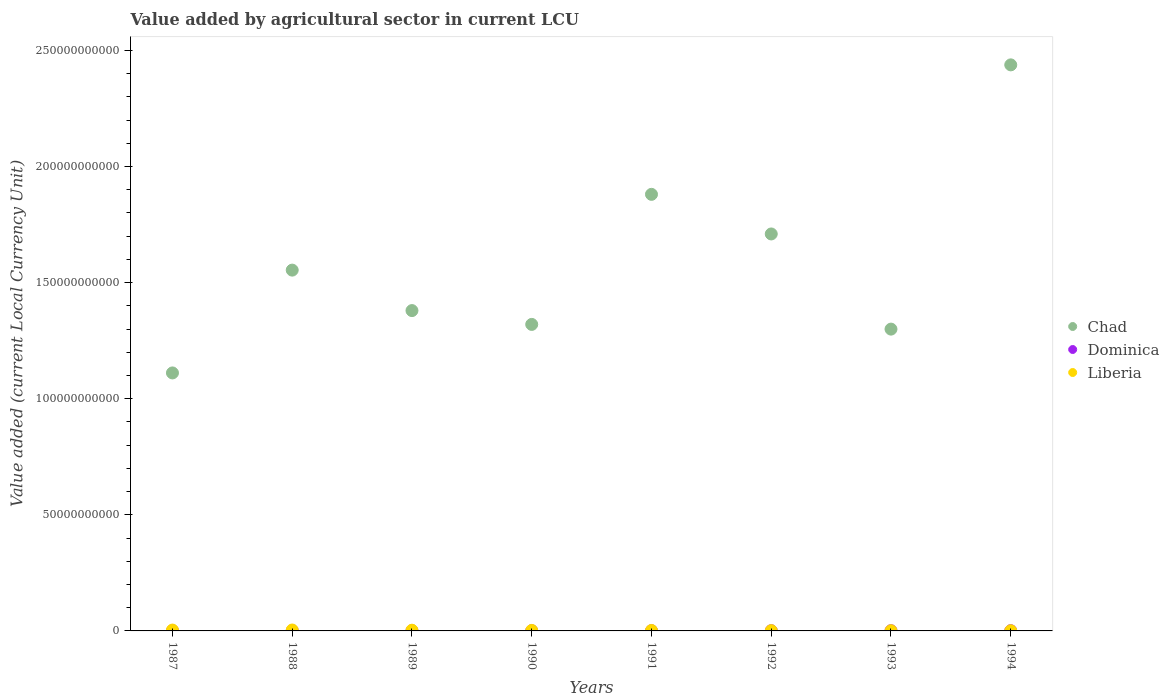How many different coloured dotlines are there?
Offer a very short reply. 3. What is the value added by agricultural sector in Liberia in 1987?
Ensure brevity in your answer.  3.71e+08. Across all years, what is the maximum value added by agricultural sector in Liberia?
Keep it short and to the point. 3.96e+08. Across all years, what is the minimum value added by agricultural sector in Liberia?
Keep it short and to the point. 6.93e+07. In which year was the value added by agricultural sector in Dominica maximum?
Offer a terse response. 1994. What is the total value added by agricultural sector in Chad in the graph?
Your answer should be very brief. 1.27e+12. What is the difference between the value added by agricultural sector in Chad in 1988 and that in 1992?
Your answer should be compact. -1.56e+1. What is the difference between the value added by agricultural sector in Liberia in 1991 and the value added by agricultural sector in Dominica in 1987?
Your response must be concise. 1.09e+08. What is the average value added by agricultural sector in Liberia per year?
Your answer should be very brief. 2.17e+08. In the year 1987, what is the difference between the value added by agricultural sector in Dominica and value added by agricultural sector in Chad?
Your response must be concise. -1.11e+11. What is the ratio of the value added by agricultural sector in Chad in 1987 to that in 1993?
Your answer should be very brief. 0.85. Is the difference between the value added by agricultural sector in Dominica in 1989 and 1990 greater than the difference between the value added by agricultural sector in Chad in 1989 and 1990?
Offer a terse response. No. What is the difference between the highest and the second highest value added by agricultural sector in Chad?
Offer a very short reply. 5.58e+1. What is the difference between the highest and the lowest value added by agricultural sector in Chad?
Give a very brief answer. 1.33e+11. Is it the case that in every year, the sum of the value added by agricultural sector in Dominica and value added by agricultural sector in Chad  is greater than the value added by agricultural sector in Liberia?
Give a very brief answer. Yes. Does the value added by agricultural sector in Chad monotonically increase over the years?
Ensure brevity in your answer.  No. How many dotlines are there?
Offer a terse response. 3. What is the difference between two consecutive major ticks on the Y-axis?
Your answer should be compact. 5.00e+1. Are the values on the major ticks of Y-axis written in scientific E-notation?
Give a very brief answer. No. Does the graph contain any zero values?
Ensure brevity in your answer.  No. How many legend labels are there?
Give a very brief answer. 3. What is the title of the graph?
Keep it short and to the point. Value added by agricultural sector in current LCU. What is the label or title of the Y-axis?
Offer a terse response. Value added (current Local Currency Unit). What is the Value added (current Local Currency Unit) in Chad in 1987?
Ensure brevity in your answer.  1.11e+11. What is the Value added (current Local Currency Unit) in Dominica in 1987?
Your response must be concise. 8.45e+07. What is the Value added (current Local Currency Unit) of Liberia in 1987?
Make the answer very short. 3.71e+08. What is the Value added (current Local Currency Unit) in Chad in 1988?
Ensure brevity in your answer.  1.55e+11. What is the Value added (current Local Currency Unit) of Dominica in 1988?
Ensure brevity in your answer.  9.08e+07. What is the Value added (current Local Currency Unit) in Liberia in 1988?
Provide a short and direct response. 3.96e+08. What is the Value added (current Local Currency Unit) of Chad in 1989?
Give a very brief answer. 1.38e+11. What is the Value added (current Local Currency Unit) in Dominica in 1989?
Offer a terse response. 8.09e+07. What is the Value added (current Local Currency Unit) of Liberia in 1989?
Offer a terse response. 3.04e+08. What is the Value added (current Local Currency Unit) in Chad in 1990?
Keep it short and to the point. 1.32e+11. What is the Value added (current Local Currency Unit) in Dominica in 1990?
Provide a short and direct response. 9.25e+07. What is the Value added (current Local Currency Unit) of Liberia in 1990?
Your answer should be very brief. 2.09e+08. What is the Value added (current Local Currency Unit) in Chad in 1991?
Make the answer very short. 1.88e+11. What is the Value added (current Local Currency Unit) in Dominica in 1991?
Your answer should be compact. 9.69e+07. What is the Value added (current Local Currency Unit) in Liberia in 1991?
Your answer should be very brief. 1.94e+08. What is the Value added (current Local Currency Unit) of Chad in 1992?
Your answer should be very brief. 1.71e+11. What is the Value added (current Local Currency Unit) in Dominica in 1992?
Offer a very short reply. 9.76e+07. What is the Value added (current Local Currency Unit) in Liberia in 1992?
Give a very brief answer. 1.15e+08. What is the Value added (current Local Currency Unit) of Chad in 1993?
Provide a short and direct response. 1.30e+11. What is the Value added (current Local Currency Unit) of Dominica in 1993?
Provide a succinct answer. 9.80e+07. What is the Value added (current Local Currency Unit) in Liberia in 1993?
Offer a terse response. 8.12e+07. What is the Value added (current Local Currency Unit) in Chad in 1994?
Provide a succinct answer. 2.44e+11. What is the Value added (current Local Currency Unit) of Dominica in 1994?
Provide a short and direct response. 1.07e+08. What is the Value added (current Local Currency Unit) in Liberia in 1994?
Your answer should be very brief. 6.93e+07. Across all years, what is the maximum Value added (current Local Currency Unit) of Chad?
Keep it short and to the point. 2.44e+11. Across all years, what is the maximum Value added (current Local Currency Unit) in Dominica?
Offer a very short reply. 1.07e+08. Across all years, what is the maximum Value added (current Local Currency Unit) in Liberia?
Provide a short and direct response. 3.96e+08. Across all years, what is the minimum Value added (current Local Currency Unit) of Chad?
Make the answer very short. 1.11e+11. Across all years, what is the minimum Value added (current Local Currency Unit) of Dominica?
Keep it short and to the point. 8.09e+07. Across all years, what is the minimum Value added (current Local Currency Unit) in Liberia?
Keep it short and to the point. 6.93e+07. What is the total Value added (current Local Currency Unit) of Chad in the graph?
Offer a terse response. 1.27e+12. What is the total Value added (current Local Currency Unit) in Dominica in the graph?
Your response must be concise. 7.49e+08. What is the total Value added (current Local Currency Unit) in Liberia in the graph?
Give a very brief answer. 1.74e+09. What is the difference between the Value added (current Local Currency Unit) of Chad in 1987 and that in 1988?
Make the answer very short. -4.43e+1. What is the difference between the Value added (current Local Currency Unit) in Dominica in 1987 and that in 1988?
Give a very brief answer. -6.37e+06. What is the difference between the Value added (current Local Currency Unit) in Liberia in 1987 and that in 1988?
Offer a very short reply. -2.48e+07. What is the difference between the Value added (current Local Currency Unit) in Chad in 1987 and that in 1989?
Offer a very short reply. -2.68e+1. What is the difference between the Value added (current Local Currency Unit) of Dominica in 1987 and that in 1989?
Make the answer very short. 3.52e+06. What is the difference between the Value added (current Local Currency Unit) in Liberia in 1987 and that in 1989?
Give a very brief answer. 6.64e+07. What is the difference between the Value added (current Local Currency Unit) in Chad in 1987 and that in 1990?
Provide a succinct answer. -2.09e+1. What is the difference between the Value added (current Local Currency Unit) of Dominica in 1987 and that in 1990?
Keep it short and to the point. -8.03e+06. What is the difference between the Value added (current Local Currency Unit) of Liberia in 1987 and that in 1990?
Provide a succinct answer. 1.62e+08. What is the difference between the Value added (current Local Currency Unit) of Chad in 1987 and that in 1991?
Offer a very short reply. -7.69e+1. What is the difference between the Value added (current Local Currency Unit) of Dominica in 1987 and that in 1991?
Offer a very short reply. -1.24e+07. What is the difference between the Value added (current Local Currency Unit) of Liberia in 1987 and that in 1991?
Give a very brief answer. 1.77e+08. What is the difference between the Value added (current Local Currency Unit) in Chad in 1987 and that in 1992?
Give a very brief answer. -5.99e+1. What is the difference between the Value added (current Local Currency Unit) in Dominica in 1987 and that in 1992?
Your answer should be compact. -1.32e+07. What is the difference between the Value added (current Local Currency Unit) in Liberia in 1987 and that in 1992?
Provide a short and direct response. 2.56e+08. What is the difference between the Value added (current Local Currency Unit) of Chad in 1987 and that in 1993?
Your answer should be compact. -1.89e+1. What is the difference between the Value added (current Local Currency Unit) of Dominica in 1987 and that in 1993?
Offer a very short reply. -1.36e+07. What is the difference between the Value added (current Local Currency Unit) in Liberia in 1987 and that in 1993?
Your answer should be compact. 2.90e+08. What is the difference between the Value added (current Local Currency Unit) of Chad in 1987 and that in 1994?
Offer a terse response. -1.33e+11. What is the difference between the Value added (current Local Currency Unit) in Dominica in 1987 and that in 1994?
Your answer should be compact. -2.29e+07. What is the difference between the Value added (current Local Currency Unit) of Liberia in 1987 and that in 1994?
Your answer should be very brief. 3.02e+08. What is the difference between the Value added (current Local Currency Unit) of Chad in 1988 and that in 1989?
Give a very brief answer. 1.74e+1. What is the difference between the Value added (current Local Currency Unit) of Dominica in 1988 and that in 1989?
Make the answer very short. 9.89e+06. What is the difference between the Value added (current Local Currency Unit) in Liberia in 1988 and that in 1989?
Offer a terse response. 9.12e+07. What is the difference between the Value added (current Local Currency Unit) of Chad in 1988 and that in 1990?
Keep it short and to the point. 2.34e+1. What is the difference between the Value added (current Local Currency Unit) in Dominica in 1988 and that in 1990?
Keep it short and to the point. -1.66e+06. What is the difference between the Value added (current Local Currency Unit) in Liberia in 1988 and that in 1990?
Give a very brief answer. 1.87e+08. What is the difference between the Value added (current Local Currency Unit) in Chad in 1988 and that in 1991?
Your response must be concise. -3.26e+1. What is the difference between the Value added (current Local Currency Unit) in Dominica in 1988 and that in 1991?
Your answer should be very brief. -6.08e+06. What is the difference between the Value added (current Local Currency Unit) of Liberia in 1988 and that in 1991?
Provide a succinct answer. 2.02e+08. What is the difference between the Value added (current Local Currency Unit) of Chad in 1988 and that in 1992?
Give a very brief answer. -1.56e+1. What is the difference between the Value added (current Local Currency Unit) of Dominica in 1988 and that in 1992?
Offer a terse response. -6.79e+06. What is the difference between the Value added (current Local Currency Unit) in Liberia in 1988 and that in 1992?
Keep it short and to the point. 2.81e+08. What is the difference between the Value added (current Local Currency Unit) in Chad in 1988 and that in 1993?
Offer a very short reply. 2.54e+1. What is the difference between the Value added (current Local Currency Unit) of Dominica in 1988 and that in 1993?
Your answer should be compact. -7.18e+06. What is the difference between the Value added (current Local Currency Unit) of Liberia in 1988 and that in 1993?
Ensure brevity in your answer.  3.14e+08. What is the difference between the Value added (current Local Currency Unit) in Chad in 1988 and that in 1994?
Provide a succinct answer. -8.84e+1. What is the difference between the Value added (current Local Currency Unit) of Dominica in 1988 and that in 1994?
Make the answer very short. -1.65e+07. What is the difference between the Value added (current Local Currency Unit) of Liberia in 1988 and that in 1994?
Your answer should be very brief. 3.26e+08. What is the difference between the Value added (current Local Currency Unit) of Chad in 1989 and that in 1990?
Your response must be concise. 5.95e+09. What is the difference between the Value added (current Local Currency Unit) of Dominica in 1989 and that in 1990?
Offer a terse response. -1.16e+07. What is the difference between the Value added (current Local Currency Unit) in Liberia in 1989 and that in 1990?
Provide a succinct answer. 9.55e+07. What is the difference between the Value added (current Local Currency Unit) in Chad in 1989 and that in 1991?
Offer a very short reply. -5.01e+1. What is the difference between the Value added (current Local Currency Unit) in Dominica in 1989 and that in 1991?
Keep it short and to the point. -1.60e+07. What is the difference between the Value added (current Local Currency Unit) of Liberia in 1989 and that in 1991?
Your answer should be compact. 1.11e+08. What is the difference between the Value added (current Local Currency Unit) in Chad in 1989 and that in 1992?
Provide a short and direct response. -3.30e+1. What is the difference between the Value added (current Local Currency Unit) in Dominica in 1989 and that in 1992?
Ensure brevity in your answer.  -1.67e+07. What is the difference between the Value added (current Local Currency Unit) in Liberia in 1989 and that in 1992?
Your answer should be very brief. 1.90e+08. What is the difference between the Value added (current Local Currency Unit) in Chad in 1989 and that in 1993?
Keep it short and to the point. 7.98e+09. What is the difference between the Value added (current Local Currency Unit) in Dominica in 1989 and that in 1993?
Your answer should be compact. -1.71e+07. What is the difference between the Value added (current Local Currency Unit) of Liberia in 1989 and that in 1993?
Offer a terse response. 2.23e+08. What is the difference between the Value added (current Local Currency Unit) in Chad in 1989 and that in 1994?
Make the answer very short. -1.06e+11. What is the difference between the Value added (current Local Currency Unit) in Dominica in 1989 and that in 1994?
Ensure brevity in your answer.  -2.64e+07. What is the difference between the Value added (current Local Currency Unit) in Liberia in 1989 and that in 1994?
Your response must be concise. 2.35e+08. What is the difference between the Value added (current Local Currency Unit) of Chad in 1990 and that in 1991?
Provide a short and direct response. -5.60e+1. What is the difference between the Value added (current Local Currency Unit) of Dominica in 1990 and that in 1991?
Offer a very short reply. -4.42e+06. What is the difference between the Value added (current Local Currency Unit) of Liberia in 1990 and that in 1991?
Ensure brevity in your answer.  1.55e+07. What is the difference between the Value added (current Local Currency Unit) of Chad in 1990 and that in 1992?
Your answer should be compact. -3.90e+1. What is the difference between the Value added (current Local Currency Unit) in Dominica in 1990 and that in 1992?
Keep it short and to the point. -5.13e+06. What is the difference between the Value added (current Local Currency Unit) of Liberia in 1990 and that in 1992?
Offer a terse response. 9.44e+07. What is the difference between the Value added (current Local Currency Unit) of Chad in 1990 and that in 1993?
Offer a terse response. 2.03e+09. What is the difference between the Value added (current Local Currency Unit) of Dominica in 1990 and that in 1993?
Provide a short and direct response. -5.52e+06. What is the difference between the Value added (current Local Currency Unit) in Liberia in 1990 and that in 1993?
Keep it short and to the point. 1.28e+08. What is the difference between the Value added (current Local Currency Unit) of Chad in 1990 and that in 1994?
Your answer should be very brief. -1.12e+11. What is the difference between the Value added (current Local Currency Unit) in Dominica in 1990 and that in 1994?
Give a very brief answer. -1.48e+07. What is the difference between the Value added (current Local Currency Unit) in Liberia in 1990 and that in 1994?
Provide a short and direct response. 1.40e+08. What is the difference between the Value added (current Local Currency Unit) in Chad in 1991 and that in 1992?
Offer a terse response. 1.71e+1. What is the difference between the Value added (current Local Currency Unit) in Dominica in 1991 and that in 1992?
Ensure brevity in your answer.  -7.10e+05. What is the difference between the Value added (current Local Currency Unit) in Liberia in 1991 and that in 1992?
Ensure brevity in your answer.  7.89e+07. What is the difference between the Value added (current Local Currency Unit) of Chad in 1991 and that in 1993?
Your response must be concise. 5.80e+1. What is the difference between the Value added (current Local Currency Unit) of Dominica in 1991 and that in 1993?
Offer a terse response. -1.10e+06. What is the difference between the Value added (current Local Currency Unit) in Liberia in 1991 and that in 1993?
Your answer should be very brief. 1.12e+08. What is the difference between the Value added (current Local Currency Unit) of Chad in 1991 and that in 1994?
Ensure brevity in your answer.  -5.58e+1. What is the difference between the Value added (current Local Currency Unit) in Dominica in 1991 and that in 1994?
Give a very brief answer. -1.04e+07. What is the difference between the Value added (current Local Currency Unit) of Liberia in 1991 and that in 1994?
Give a very brief answer. 1.24e+08. What is the difference between the Value added (current Local Currency Unit) of Chad in 1992 and that in 1993?
Make the answer very short. 4.10e+1. What is the difference between the Value added (current Local Currency Unit) of Dominica in 1992 and that in 1993?
Offer a terse response. -3.90e+05. What is the difference between the Value added (current Local Currency Unit) of Liberia in 1992 and that in 1993?
Provide a short and direct response. 3.34e+07. What is the difference between the Value added (current Local Currency Unit) in Chad in 1992 and that in 1994?
Your answer should be compact. -7.28e+1. What is the difference between the Value added (current Local Currency Unit) of Dominica in 1992 and that in 1994?
Provide a succinct answer. -9.72e+06. What is the difference between the Value added (current Local Currency Unit) of Liberia in 1992 and that in 1994?
Ensure brevity in your answer.  4.53e+07. What is the difference between the Value added (current Local Currency Unit) of Chad in 1993 and that in 1994?
Your response must be concise. -1.14e+11. What is the difference between the Value added (current Local Currency Unit) in Dominica in 1993 and that in 1994?
Your answer should be compact. -9.33e+06. What is the difference between the Value added (current Local Currency Unit) of Liberia in 1993 and that in 1994?
Your answer should be compact. 1.19e+07. What is the difference between the Value added (current Local Currency Unit) of Chad in 1987 and the Value added (current Local Currency Unit) of Dominica in 1988?
Ensure brevity in your answer.  1.11e+11. What is the difference between the Value added (current Local Currency Unit) of Chad in 1987 and the Value added (current Local Currency Unit) of Liberia in 1988?
Give a very brief answer. 1.11e+11. What is the difference between the Value added (current Local Currency Unit) in Dominica in 1987 and the Value added (current Local Currency Unit) in Liberia in 1988?
Your response must be concise. -3.11e+08. What is the difference between the Value added (current Local Currency Unit) in Chad in 1987 and the Value added (current Local Currency Unit) in Dominica in 1989?
Provide a succinct answer. 1.11e+11. What is the difference between the Value added (current Local Currency Unit) of Chad in 1987 and the Value added (current Local Currency Unit) of Liberia in 1989?
Offer a very short reply. 1.11e+11. What is the difference between the Value added (current Local Currency Unit) of Dominica in 1987 and the Value added (current Local Currency Unit) of Liberia in 1989?
Ensure brevity in your answer.  -2.20e+08. What is the difference between the Value added (current Local Currency Unit) in Chad in 1987 and the Value added (current Local Currency Unit) in Dominica in 1990?
Your response must be concise. 1.11e+11. What is the difference between the Value added (current Local Currency Unit) of Chad in 1987 and the Value added (current Local Currency Unit) of Liberia in 1990?
Provide a short and direct response. 1.11e+11. What is the difference between the Value added (current Local Currency Unit) of Dominica in 1987 and the Value added (current Local Currency Unit) of Liberia in 1990?
Ensure brevity in your answer.  -1.25e+08. What is the difference between the Value added (current Local Currency Unit) of Chad in 1987 and the Value added (current Local Currency Unit) of Dominica in 1991?
Provide a short and direct response. 1.11e+11. What is the difference between the Value added (current Local Currency Unit) in Chad in 1987 and the Value added (current Local Currency Unit) in Liberia in 1991?
Provide a short and direct response. 1.11e+11. What is the difference between the Value added (current Local Currency Unit) of Dominica in 1987 and the Value added (current Local Currency Unit) of Liberia in 1991?
Provide a succinct answer. -1.09e+08. What is the difference between the Value added (current Local Currency Unit) of Chad in 1987 and the Value added (current Local Currency Unit) of Dominica in 1992?
Offer a very short reply. 1.11e+11. What is the difference between the Value added (current Local Currency Unit) in Chad in 1987 and the Value added (current Local Currency Unit) in Liberia in 1992?
Your answer should be very brief. 1.11e+11. What is the difference between the Value added (current Local Currency Unit) of Dominica in 1987 and the Value added (current Local Currency Unit) of Liberia in 1992?
Your response must be concise. -3.01e+07. What is the difference between the Value added (current Local Currency Unit) of Chad in 1987 and the Value added (current Local Currency Unit) of Dominica in 1993?
Keep it short and to the point. 1.11e+11. What is the difference between the Value added (current Local Currency Unit) of Chad in 1987 and the Value added (current Local Currency Unit) of Liberia in 1993?
Provide a succinct answer. 1.11e+11. What is the difference between the Value added (current Local Currency Unit) of Dominica in 1987 and the Value added (current Local Currency Unit) of Liberia in 1993?
Provide a short and direct response. 3.26e+06. What is the difference between the Value added (current Local Currency Unit) of Chad in 1987 and the Value added (current Local Currency Unit) of Dominica in 1994?
Provide a succinct answer. 1.11e+11. What is the difference between the Value added (current Local Currency Unit) in Chad in 1987 and the Value added (current Local Currency Unit) in Liberia in 1994?
Your answer should be compact. 1.11e+11. What is the difference between the Value added (current Local Currency Unit) of Dominica in 1987 and the Value added (current Local Currency Unit) of Liberia in 1994?
Your response must be concise. 1.52e+07. What is the difference between the Value added (current Local Currency Unit) of Chad in 1988 and the Value added (current Local Currency Unit) of Dominica in 1989?
Make the answer very short. 1.55e+11. What is the difference between the Value added (current Local Currency Unit) in Chad in 1988 and the Value added (current Local Currency Unit) in Liberia in 1989?
Your answer should be compact. 1.55e+11. What is the difference between the Value added (current Local Currency Unit) in Dominica in 1988 and the Value added (current Local Currency Unit) in Liberia in 1989?
Provide a succinct answer. -2.14e+08. What is the difference between the Value added (current Local Currency Unit) of Chad in 1988 and the Value added (current Local Currency Unit) of Dominica in 1990?
Make the answer very short. 1.55e+11. What is the difference between the Value added (current Local Currency Unit) of Chad in 1988 and the Value added (current Local Currency Unit) of Liberia in 1990?
Your answer should be very brief. 1.55e+11. What is the difference between the Value added (current Local Currency Unit) of Dominica in 1988 and the Value added (current Local Currency Unit) of Liberia in 1990?
Your answer should be compact. -1.18e+08. What is the difference between the Value added (current Local Currency Unit) of Chad in 1988 and the Value added (current Local Currency Unit) of Dominica in 1991?
Offer a terse response. 1.55e+11. What is the difference between the Value added (current Local Currency Unit) of Chad in 1988 and the Value added (current Local Currency Unit) of Liberia in 1991?
Keep it short and to the point. 1.55e+11. What is the difference between the Value added (current Local Currency Unit) of Dominica in 1988 and the Value added (current Local Currency Unit) of Liberia in 1991?
Keep it short and to the point. -1.03e+08. What is the difference between the Value added (current Local Currency Unit) in Chad in 1988 and the Value added (current Local Currency Unit) in Dominica in 1992?
Your response must be concise. 1.55e+11. What is the difference between the Value added (current Local Currency Unit) in Chad in 1988 and the Value added (current Local Currency Unit) in Liberia in 1992?
Your answer should be very brief. 1.55e+11. What is the difference between the Value added (current Local Currency Unit) in Dominica in 1988 and the Value added (current Local Currency Unit) in Liberia in 1992?
Make the answer very short. -2.38e+07. What is the difference between the Value added (current Local Currency Unit) in Chad in 1988 and the Value added (current Local Currency Unit) in Dominica in 1993?
Give a very brief answer. 1.55e+11. What is the difference between the Value added (current Local Currency Unit) of Chad in 1988 and the Value added (current Local Currency Unit) of Liberia in 1993?
Keep it short and to the point. 1.55e+11. What is the difference between the Value added (current Local Currency Unit) of Dominica in 1988 and the Value added (current Local Currency Unit) of Liberia in 1993?
Keep it short and to the point. 9.63e+06. What is the difference between the Value added (current Local Currency Unit) in Chad in 1988 and the Value added (current Local Currency Unit) in Dominica in 1994?
Offer a very short reply. 1.55e+11. What is the difference between the Value added (current Local Currency Unit) in Chad in 1988 and the Value added (current Local Currency Unit) in Liberia in 1994?
Your answer should be compact. 1.55e+11. What is the difference between the Value added (current Local Currency Unit) in Dominica in 1988 and the Value added (current Local Currency Unit) in Liberia in 1994?
Your answer should be compact. 2.15e+07. What is the difference between the Value added (current Local Currency Unit) of Chad in 1989 and the Value added (current Local Currency Unit) of Dominica in 1990?
Give a very brief answer. 1.38e+11. What is the difference between the Value added (current Local Currency Unit) in Chad in 1989 and the Value added (current Local Currency Unit) in Liberia in 1990?
Make the answer very short. 1.38e+11. What is the difference between the Value added (current Local Currency Unit) of Dominica in 1989 and the Value added (current Local Currency Unit) of Liberia in 1990?
Your response must be concise. -1.28e+08. What is the difference between the Value added (current Local Currency Unit) in Chad in 1989 and the Value added (current Local Currency Unit) in Dominica in 1991?
Your response must be concise. 1.38e+11. What is the difference between the Value added (current Local Currency Unit) in Chad in 1989 and the Value added (current Local Currency Unit) in Liberia in 1991?
Your answer should be compact. 1.38e+11. What is the difference between the Value added (current Local Currency Unit) of Dominica in 1989 and the Value added (current Local Currency Unit) of Liberia in 1991?
Offer a terse response. -1.13e+08. What is the difference between the Value added (current Local Currency Unit) of Chad in 1989 and the Value added (current Local Currency Unit) of Dominica in 1992?
Provide a short and direct response. 1.38e+11. What is the difference between the Value added (current Local Currency Unit) in Chad in 1989 and the Value added (current Local Currency Unit) in Liberia in 1992?
Your answer should be compact. 1.38e+11. What is the difference between the Value added (current Local Currency Unit) in Dominica in 1989 and the Value added (current Local Currency Unit) in Liberia in 1992?
Ensure brevity in your answer.  -3.37e+07. What is the difference between the Value added (current Local Currency Unit) of Chad in 1989 and the Value added (current Local Currency Unit) of Dominica in 1993?
Offer a very short reply. 1.38e+11. What is the difference between the Value added (current Local Currency Unit) of Chad in 1989 and the Value added (current Local Currency Unit) of Liberia in 1993?
Make the answer very short. 1.38e+11. What is the difference between the Value added (current Local Currency Unit) in Chad in 1989 and the Value added (current Local Currency Unit) in Dominica in 1994?
Make the answer very short. 1.38e+11. What is the difference between the Value added (current Local Currency Unit) in Chad in 1989 and the Value added (current Local Currency Unit) in Liberia in 1994?
Offer a terse response. 1.38e+11. What is the difference between the Value added (current Local Currency Unit) of Dominica in 1989 and the Value added (current Local Currency Unit) of Liberia in 1994?
Make the answer very short. 1.16e+07. What is the difference between the Value added (current Local Currency Unit) of Chad in 1990 and the Value added (current Local Currency Unit) of Dominica in 1991?
Your answer should be very brief. 1.32e+11. What is the difference between the Value added (current Local Currency Unit) in Chad in 1990 and the Value added (current Local Currency Unit) in Liberia in 1991?
Offer a terse response. 1.32e+11. What is the difference between the Value added (current Local Currency Unit) of Dominica in 1990 and the Value added (current Local Currency Unit) of Liberia in 1991?
Make the answer very short. -1.01e+08. What is the difference between the Value added (current Local Currency Unit) of Chad in 1990 and the Value added (current Local Currency Unit) of Dominica in 1992?
Give a very brief answer. 1.32e+11. What is the difference between the Value added (current Local Currency Unit) in Chad in 1990 and the Value added (current Local Currency Unit) in Liberia in 1992?
Your response must be concise. 1.32e+11. What is the difference between the Value added (current Local Currency Unit) of Dominica in 1990 and the Value added (current Local Currency Unit) of Liberia in 1992?
Your answer should be compact. -2.21e+07. What is the difference between the Value added (current Local Currency Unit) in Chad in 1990 and the Value added (current Local Currency Unit) in Dominica in 1993?
Offer a terse response. 1.32e+11. What is the difference between the Value added (current Local Currency Unit) in Chad in 1990 and the Value added (current Local Currency Unit) in Liberia in 1993?
Your answer should be very brief. 1.32e+11. What is the difference between the Value added (current Local Currency Unit) in Dominica in 1990 and the Value added (current Local Currency Unit) in Liberia in 1993?
Your answer should be compact. 1.13e+07. What is the difference between the Value added (current Local Currency Unit) of Chad in 1990 and the Value added (current Local Currency Unit) of Dominica in 1994?
Your response must be concise. 1.32e+11. What is the difference between the Value added (current Local Currency Unit) of Chad in 1990 and the Value added (current Local Currency Unit) of Liberia in 1994?
Offer a very short reply. 1.32e+11. What is the difference between the Value added (current Local Currency Unit) of Dominica in 1990 and the Value added (current Local Currency Unit) of Liberia in 1994?
Provide a succinct answer. 2.32e+07. What is the difference between the Value added (current Local Currency Unit) of Chad in 1991 and the Value added (current Local Currency Unit) of Dominica in 1992?
Keep it short and to the point. 1.88e+11. What is the difference between the Value added (current Local Currency Unit) in Chad in 1991 and the Value added (current Local Currency Unit) in Liberia in 1992?
Provide a succinct answer. 1.88e+11. What is the difference between the Value added (current Local Currency Unit) of Dominica in 1991 and the Value added (current Local Currency Unit) of Liberia in 1992?
Provide a succinct answer. -1.77e+07. What is the difference between the Value added (current Local Currency Unit) in Chad in 1991 and the Value added (current Local Currency Unit) in Dominica in 1993?
Offer a terse response. 1.88e+11. What is the difference between the Value added (current Local Currency Unit) in Chad in 1991 and the Value added (current Local Currency Unit) in Liberia in 1993?
Provide a succinct answer. 1.88e+11. What is the difference between the Value added (current Local Currency Unit) of Dominica in 1991 and the Value added (current Local Currency Unit) of Liberia in 1993?
Offer a very short reply. 1.57e+07. What is the difference between the Value added (current Local Currency Unit) of Chad in 1991 and the Value added (current Local Currency Unit) of Dominica in 1994?
Your answer should be compact. 1.88e+11. What is the difference between the Value added (current Local Currency Unit) in Chad in 1991 and the Value added (current Local Currency Unit) in Liberia in 1994?
Keep it short and to the point. 1.88e+11. What is the difference between the Value added (current Local Currency Unit) in Dominica in 1991 and the Value added (current Local Currency Unit) in Liberia in 1994?
Provide a succinct answer. 2.76e+07. What is the difference between the Value added (current Local Currency Unit) in Chad in 1992 and the Value added (current Local Currency Unit) in Dominica in 1993?
Give a very brief answer. 1.71e+11. What is the difference between the Value added (current Local Currency Unit) of Chad in 1992 and the Value added (current Local Currency Unit) of Liberia in 1993?
Keep it short and to the point. 1.71e+11. What is the difference between the Value added (current Local Currency Unit) in Dominica in 1992 and the Value added (current Local Currency Unit) in Liberia in 1993?
Your response must be concise. 1.64e+07. What is the difference between the Value added (current Local Currency Unit) in Chad in 1992 and the Value added (current Local Currency Unit) in Dominica in 1994?
Provide a succinct answer. 1.71e+11. What is the difference between the Value added (current Local Currency Unit) of Chad in 1992 and the Value added (current Local Currency Unit) of Liberia in 1994?
Keep it short and to the point. 1.71e+11. What is the difference between the Value added (current Local Currency Unit) in Dominica in 1992 and the Value added (current Local Currency Unit) in Liberia in 1994?
Provide a succinct answer. 2.83e+07. What is the difference between the Value added (current Local Currency Unit) in Chad in 1993 and the Value added (current Local Currency Unit) in Dominica in 1994?
Your response must be concise. 1.30e+11. What is the difference between the Value added (current Local Currency Unit) of Chad in 1993 and the Value added (current Local Currency Unit) of Liberia in 1994?
Offer a very short reply. 1.30e+11. What is the difference between the Value added (current Local Currency Unit) in Dominica in 1993 and the Value added (current Local Currency Unit) in Liberia in 1994?
Provide a short and direct response. 2.87e+07. What is the average Value added (current Local Currency Unit) in Chad per year?
Offer a terse response. 1.59e+11. What is the average Value added (current Local Currency Unit) of Dominica per year?
Provide a succinct answer. 9.36e+07. What is the average Value added (current Local Currency Unit) of Liberia per year?
Your answer should be very brief. 2.17e+08. In the year 1987, what is the difference between the Value added (current Local Currency Unit) of Chad and Value added (current Local Currency Unit) of Dominica?
Your answer should be very brief. 1.11e+11. In the year 1987, what is the difference between the Value added (current Local Currency Unit) in Chad and Value added (current Local Currency Unit) in Liberia?
Offer a terse response. 1.11e+11. In the year 1987, what is the difference between the Value added (current Local Currency Unit) of Dominica and Value added (current Local Currency Unit) of Liberia?
Provide a short and direct response. -2.86e+08. In the year 1988, what is the difference between the Value added (current Local Currency Unit) of Chad and Value added (current Local Currency Unit) of Dominica?
Your answer should be very brief. 1.55e+11. In the year 1988, what is the difference between the Value added (current Local Currency Unit) of Chad and Value added (current Local Currency Unit) of Liberia?
Give a very brief answer. 1.55e+11. In the year 1988, what is the difference between the Value added (current Local Currency Unit) in Dominica and Value added (current Local Currency Unit) in Liberia?
Ensure brevity in your answer.  -3.05e+08. In the year 1989, what is the difference between the Value added (current Local Currency Unit) in Chad and Value added (current Local Currency Unit) in Dominica?
Your answer should be very brief. 1.38e+11. In the year 1989, what is the difference between the Value added (current Local Currency Unit) of Chad and Value added (current Local Currency Unit) of Liberia?
Offer a terse response. 1.38e+11. In the year 1989, what is the difference between the Value added (current Local Currency Unit) of Dominica and Value added (current Local Currency Unit) of Liberia?
Your response must be concise. -2.24e+08. In the year 1990, what is the difference between the Value added (current Local Currency Unit) of Chad and Value added (current Local Currency Unit) of Dominica?
Ensure brevity in your answer.  1.32e+11. In the year 1990, what is the difference between the Value added (current Local Currency Unit) in Chad and Value added (current Local Currency Unit) in Liberia?
Offer a terse response. 1.32e+11. In the year 1990, what is the difference between the Value added (current Local Currency Unit) in Dominica and Value added (current Local Currency Unit) in Liberia?
Provide a short and direct response. -1.17e+08. In the year 1991, what is the difference between the Value added (current Local Currency Unit) of Chad and Value added (current Local Currency Unit) of Dominica?
Make the answer very short. 1.88e+11. In the year 1991, what is the difference between the Value added (current Local Currency Unit) in Chad and Value added (current Local Currency Unit) in Liberia?
Your answer should be very brief. 1.88e+11. In the year 1991, what is the difference between the Value added (current Local Currency Unit) of Dominica and Value added (current Local Currency Unit) of Liberia?
Your response must be concise. -9.66e+07. In the year 1992, what is the difference between the Value added (current Local Currency Unit) of Chad and Value added (current Local Currency Unit) of Dominica?
Provide a short and direct response. 1.71e+11. In the year 1992, what is the difference between the Value added (current Local Currency Unit) of Chad and Value added (current Local Currency Unit) of Liberia?
Provide a succinct answer. 1.71e+11. In the year 1992, what is the difference between the Value added (current Local Currency Unit) in Dominica and Value added (current Local Currency Unit) in Liberia?
Offer a very short reply. -1.70e+07. In the year 1993, what is the difference between the Value added (current Local Currency Unit) in Chad and Value added (current Local Currency Unit) in Dominica?
Keep it short and to the point. 1.30e+11. In the year 1993, what is the difference between the Value added (current Local Currency Unit) in Chad and Value added (current Local Currency Unit) in Liberia?
Give a very brief answer. 1.30e+11. In the year 1993, what is the difference between the Value added (current Local Currency Unit) of Dominica and Value added (current Local Currency Unit) of Liberia?
Your answer should be very brief. 1.68e+07. In the year 1994, what is the difference between the Value added (current Local Currency Unit) in Chad and Value added (current Local Currency Unit) in Dominica?
Give a very brief answer. 2.44e+11. In the year 1994, what is the difference between the Value added (current Local Currency Unit) of Chad and Value added (current Local Currency Unit) of Liberia?
Keep it short and to the point. 2.44e+11. In the year 1994, what is the difference between the Value added (current Local Currency Unit) in Dominica and Value added (current Local Currency Unit) in Liberia?
Ensure brevity in your answer.  3.80e+07. What is the ratio of the Value added (current Local Currency Unit) in Chad in 1987 to that in 1988?
Your answer should be very brief. 0.72. What is the ratio of the Value added (current Local Currency Unit) of Dominica in 1987 to that in 1988?
Keep it short and to the point. 0.93. What is the ratio of the Value added (current Local Currency Unit) of Liberia in 1987 to that in 1988?
Offer a terse response. 0.94. What is the ratio of the Value added (current Local Currency Unit) in Chad in 1987 to that in 1989?
Provide a short and direct response. 0.81. What is the ratio of the Value added (current Local Currency Unit) of Dominica in 1987 to that in 1989?
Your response must be concise. 1.04. What is the ratio of the Value added (current Local Currency Unit) in Liberia in 1987 to that in 1989?
Provide a succinct answer. 1.22. What is the ratio of the Value added (current Local Currency Unit) of Chad in 1987 to that in 1990?
Make the answer very short. 0.84. What is the ratio of the Value added (current Local Currency Unit) in Dominica in 1987 to that in 1990?
Offer a very short reply. 0.91. What is the ratio of the Value added (current Local Currency Unit) in Liberia in 1987 to that in 1990?
Your response must be concise. 1.77. What is the ratio of the Value added (current Local Currency Unit) of Chad in 1987 to that in 1991?
Ensure brevity in your answer.  0.59. What is the ratio of the Value added (current Local Currency Unit) in Dominica in 1987 to that in 1991?
Give a very brief answer. 0.87. What is the ratio of the Value added (current Local Currency Unit) in Liberia in 1987 to that in 1991?
Provide a succinct answer. 1.92. What is the ratio of the Value added (current Local Currency Unit) of Chad in 1987 to that in 1992?
Provide a succinct answer. 0.65. What is the ratio of the Value added (current Local Currency Unit) in Dominica in 1987 to that in 1992?
Provide a short and direct response. 0.87. What is the ratio of the Value added (current Local Currency Unit) in Liberia in 1987 to that in 1992?
Offer a terse response. 3.24. What is the ratio of the Value added (current Local Currency Unit) of Chad in 1987 to that in 1993?
Keep it short and to the point. 0.85. What is the ratio of the Value added (current Local Currency Unit) of Dominica in 1987 to that in 1993?
Offer a terse response. 0.86. What is the ratio of the Value added (current Local Currency Unit) of Liberia in 1987 to that in 1993?
Offer a very short reply. 4.57. What is the ratio of the Value added (current Local Currency Unit) of Chad in 1987 to that in 1994?
Give a very brief answer. 0.46. What is the ratio of the Value added (current Local Currency Unit) of Dominica in 1987 to that in 1994?
Make the answer very short. 0.79. What is the ratio of the Value added (current Local Currency Unit) of Liberia in 1987 to that in 1994?
Your answer should be compact. 5.35. What is the ratio of the Value added (current Local Currency Unit) of Chad in 1988 to that in 1989?
Provide a succinct answer. 1.13. What is the ratio of the Value added (current Local Currency Unit) of Dominica in 1988 to that in 1989?
Keep it short and to the point. 1.12. What is the ratio of the Value added (current Local Currency Unit) in Liberia in 1988 to that in 1989?
Your answer should be compact. 1.3. What is the ratio of the Value added (current Local Currency Unit) of Chad in 1988 to that in 1990?
Your response must be concise. 1.18. What is the ratio of the Value added (current Local Currency Unit) of Dominica in 1988 to that in 1990?
Keep it short and to the point. 0.98. What is the ratio of the Value added (current Local Currency Unit) in Liberia in 1988 to that in 1990?
Provide a short and direct response. 1.89. What is the ratio of the Value added (current Local Currency Unit) in Chad in 1988 to that in 1991?
Your response must be concise. 0.83. What is the ratio of the Value added (current Local Currency Unit) in Dominica in 1988 to that in 1991?
Give a very brief answer. 0.94. What is the ratio of the Value added (current Local Currency Unit) in Liberia in 1988 to that in 1991?
Provide a short and direct response. 2.04. What is the ratio of the Value added (current Local Currency Unit) in Chad in 1988 to that in 1992?
Give a very brief answer. 0.91. What is the ratio of the Value added (current Local Currency Unit) in Dominica in 1988 to that in 1992?
Give a very brief answer. 0.93. What is the ratio of the Value added (current Local Currency Unit) in Liberia in 1988 to that in 1992?
Give a very brief answer. 3.45. What is the ratio of the Value added (current Local Currency Unit) in Chad in 1988 to that in 1993?
Keep it short and to the point. 1.2. What is the ratio of the Value added (current Local Currency Unit) in Dominica in 1988 to that in 1993?
Offer a very short reply. 0.93. What is the ratio of the Value added (current Local Currency Unit) of Liberia in 1988 to that in 1993?
Give a very brief answer. 4.87. What is the ratio of the Value added (current Local Currency Unit) in Chad in 1988 to that in 1994?
Your answer should be very brief. 0.64. What is the ratio of the Value added (current Local Currency Unit) in Dominica in 1988 to that in 1994?
Your response must be concise. 0.85. What is the ratio of the Value added (current Local Currency Unit) of Liberia in 1988 to that in 1994?
Give a very brief answer. 5.71. What is the ratio of the Value added (current Local Currency Unit) of Chad in 1989 to that in 1990?
Provide a short and direct response. 1.05. What is the ratio of the Value added (current Local Currency Unit) of Dominica in 1989 to that in 1990?
Offer a terse response. 0.88. What is the ratio of the Value added (current Local Currency Unit) of Liberia in 1989 to that in 1990?
Give a very brief answer. 1.46. What is the ratio of the Value added (current Local Currency Unit) of Chad in 1989 to that in 1991?
Ensure brevity in your answer.  0.73. What is the ratio of the Value added (current Local Currency Unit) in Dominica in 1989 to that in 1991?
Provide a short and direct response. 0.84. What is the ratio of the Value added (current Local Currency Unit) of Liberia in 1989 to that in 1991?
Provide a succinct answer. 1.57. What is the ratio of the Value added (current Local Currency Unit) of Chad in 1989 to that in 1992?
Offer a very short reply. 0.81. What is the ratio of the Value added (current Local Currency Unit) in Dominica in 1989 to that in 1992?
Your answer should be compact. 0.83. What is the ratio of the Value added (current Local Currency Unit) of Liberia in 1989 to that in 1992?
Offer a terse response. 2.66. What is the ratio of the Value added (current Local Currency Unit) in Chad in 1989 to that in 1993?
Your answer should be very brief. 1.06. What is the ratio of the Value added (current Local Currency Unit) in Dominica in 1989 to that in 1993?
Make the answer very short. 0.83. What is the ratio of the Value added (current Local Currency Unit) in Liberia in 1989 to that in 1993?
Provide a succinct answer. 3.75. What is the ratio of the Value added (current Local Currency Unit) in Chad in 1989 to that in 1994?
Your response must be concise. 0.57. What is the ratio of the Value added (current Local Currency Unit) in Dominica in 1989 to that in 1994?
Your answer should be compact. 0.75. What is the ratio of the Value added (current Local Currency Unit) of Liberia in 1989 to that in 1994?
Your response must be concise. 4.39. What is the ratio of the Value added (current Local Currency Unit) of Chad in 1990 to that in 1991?
Provide a short and direct response. 0.7. What is the ratio of the Value added (current Local Currency Unit) in Dominica in 1990 to that in 1991?
Your response must be concise. 0.95. What is the ratio of the Value added (current Local Currency Unit) of Liberia in 1990 to that in 1991?
Offer a very short reply. 1.08. What is the ratio of the Value added (current Local Currency Unit) of Chad in 1990 to that in 1992?
Offer a very short reply. 0.77. What is the ratio of the Value added (current Local Currency Unit) of Dominica in 1990 to that in 1992?
Your answer should be compact. 0.95. What is the ratio of the Value added (current Local Currency Unit) in Liberia in 1990 to that in 1992?
Offer a very short reply. 1.82. What is the ratio of the Value added (current Local Currency Unit) in Chad in 1990 to that in 1993?
Your response must be concise. 1.02. What is the ratio of the Value added (current Local Currency Unit) in Dominica in 1990 to that in 1993?
Give a very brief answer. 0.94. What is the ratio of the Value added (current Local Currency Unit) of Liberia in 1990 to that in 1993?
Ensure brevity in your answer.  2.57. What is the ratio of the Value added (current Local Currency Unit) in Chad in 1990 to that in 1994?
Make the answer very short. 0.54. What is the ratio of the Value added (current Local Currency Unit) in Dominica in 1990 to that in 1994?
Your answer should be compact. 0.86. What is the ratio of the Value added (current Local Currency Unit) in Liberia in 1990 to that in 1994?
Ensure brevity in your answer.  3.02. What is the ratio of the Value added (current Local Currency Unit) of Chad in 1991 to that in 1992?
Your answer should be very brief. 1.1. What is the ratio of the Value added (current Local Currency Unit) of Liberia in 1991 to that in 1992?
Make the answer very short. 1.69. What is the ratio of the Value added (current Local Currency Unit) in Chad in 1991 to that in 1993?
Make the answer very short. 1.45. What is the ratio of the Value added (current Local Currency Unit) of Liberia in 1991 to that in 1993?
Provide a short and direct response. 2.38. What is the ratio of the Value added (current Local Currency Unit) in Chad in 1991 to that in 1994?
Provide a succinct answer. 0.77. What is the ratio of the Value added (current Local Currency Unit) of Dominica in 1991 to that in 1994?
Your answer should be compact. 0.9. What is the ratio of the Value added (current Local Currency Unit) in Liberia in 1991 to that in 1994?
Give a very brief answer. 2.79. What is the ratio of the Value added (current Local Currency Unit) in Chad in 1992 to that in 1993?
Offer a very short reply. 1.32. What is the ratio of the Value added (current Local Currency Unit) of Dominica in 1992 to that in 1993?
Provide a succinct answer. 1. What is the ratio of the Value added (current Local Currency Unit) in Liberia in 1992 to that in 1993?
Offer a very short reply. 1.41. What is the ratio of the Value added (current Local Currency Unit) in Chad in 1992 to that in 1994?
Keep it short and to the point. 0.7. What is the ratio of the Value added (current Local Currency Unit) of Dominica in 1992 to that in 1994?
Give a very brief answer. 0.91. What is the ratio of the Value added (current Local Currency Unit) in Liberia in 1992 to that in 1994?
Provide a succinct answer. 1.65. What is the ratio of the Value added (current Local Currency Unit) in Chad in 1993 to that in 1994?
Offer a very short reply. 0.53. What is the ratio of the Value added (current Local Currency Unit) of Dominica in 1993 to that in 1994?
Your answer should be very brief. 0.91. What is the ratio of the Value added (current Local Currency Unit) of Liberia in 1993 to that in 1994?
Keep it short and to the point. 1.17. What is the difference between the highest and the second highest Value added (current Local Currency Unit) of Chad?
Ensure brevity in your answer.  5.58e+1. What is the difference between the highest and the second highest Value added (current Local Currency Unit) in Dominica?
Your response must be concise. 9.33e+06. What is the difference between the highest and the second highest Value added (current Local Currency Unit) of Liberia?
Make the answer very short. 2.48e+07. What is the difference between the highest and the lowest Value added (current Local Currency Unit) of Chad?
Make the answer very short. 1.33e+11. What is the difference between the highest and the lowest Value added (current Local Currency Unit) of Dominica?
Offer a very short reply. 2.64e+07. What is the difference between the highest and the lowest Value added (current Local Currency Unit) in Liberia?
Offer a terse response. 3.26e+08. 